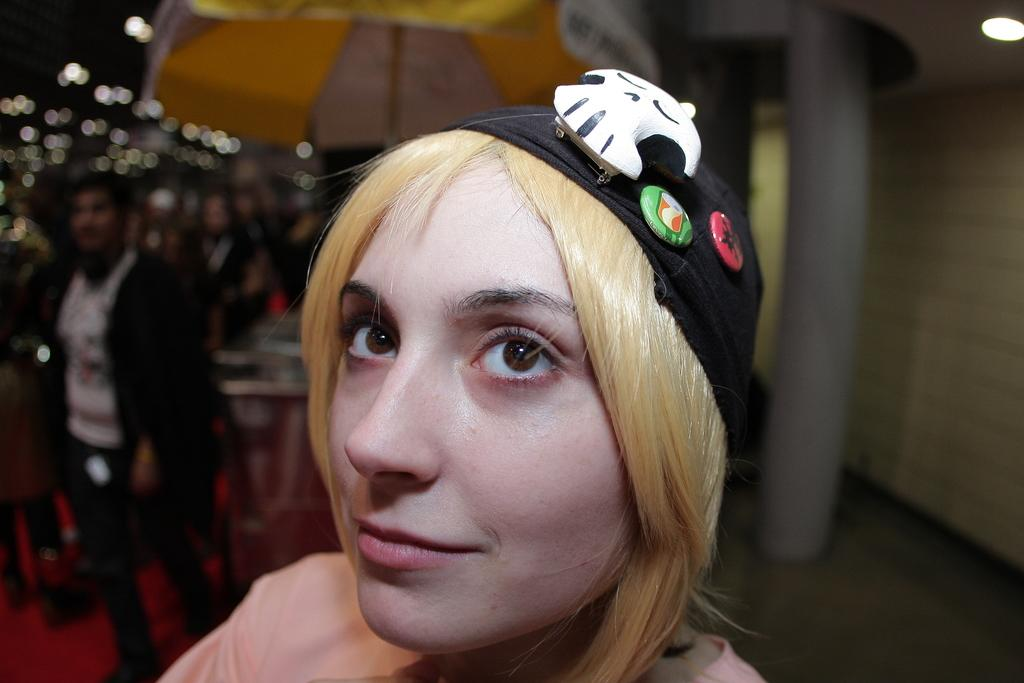What is the main subject of the image? There is a person standing in the image. What is the person in the image wearing on their upper body? The person is wearing a light pink color shirt. What type of headwear is the person wearing? The person is wearing a black color cap. Can you describe the background of the image? There is another person standing in the background of the image, and there are lights visible in the background. What type of mark can be seen on the person's back in the image? There is no mark visible on the person's back in the image. What committee is responsible for organizing the event in the image? There is no event or committee mentioned or depicted in the image. 